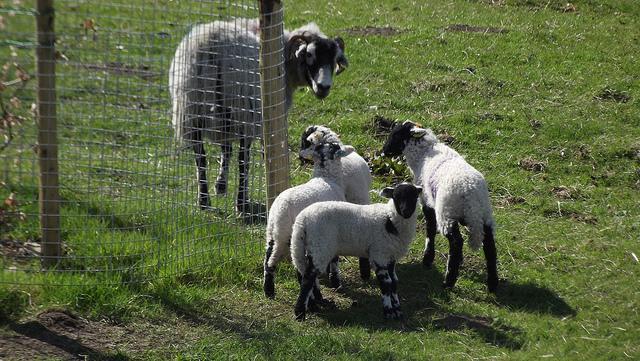How many babies are there?
Give a very brief answer. 3. How many sheep are there?
Give a very brief answer. 4. How many people in the picture are wearing black caps?
Give a very brief answer. 0. 